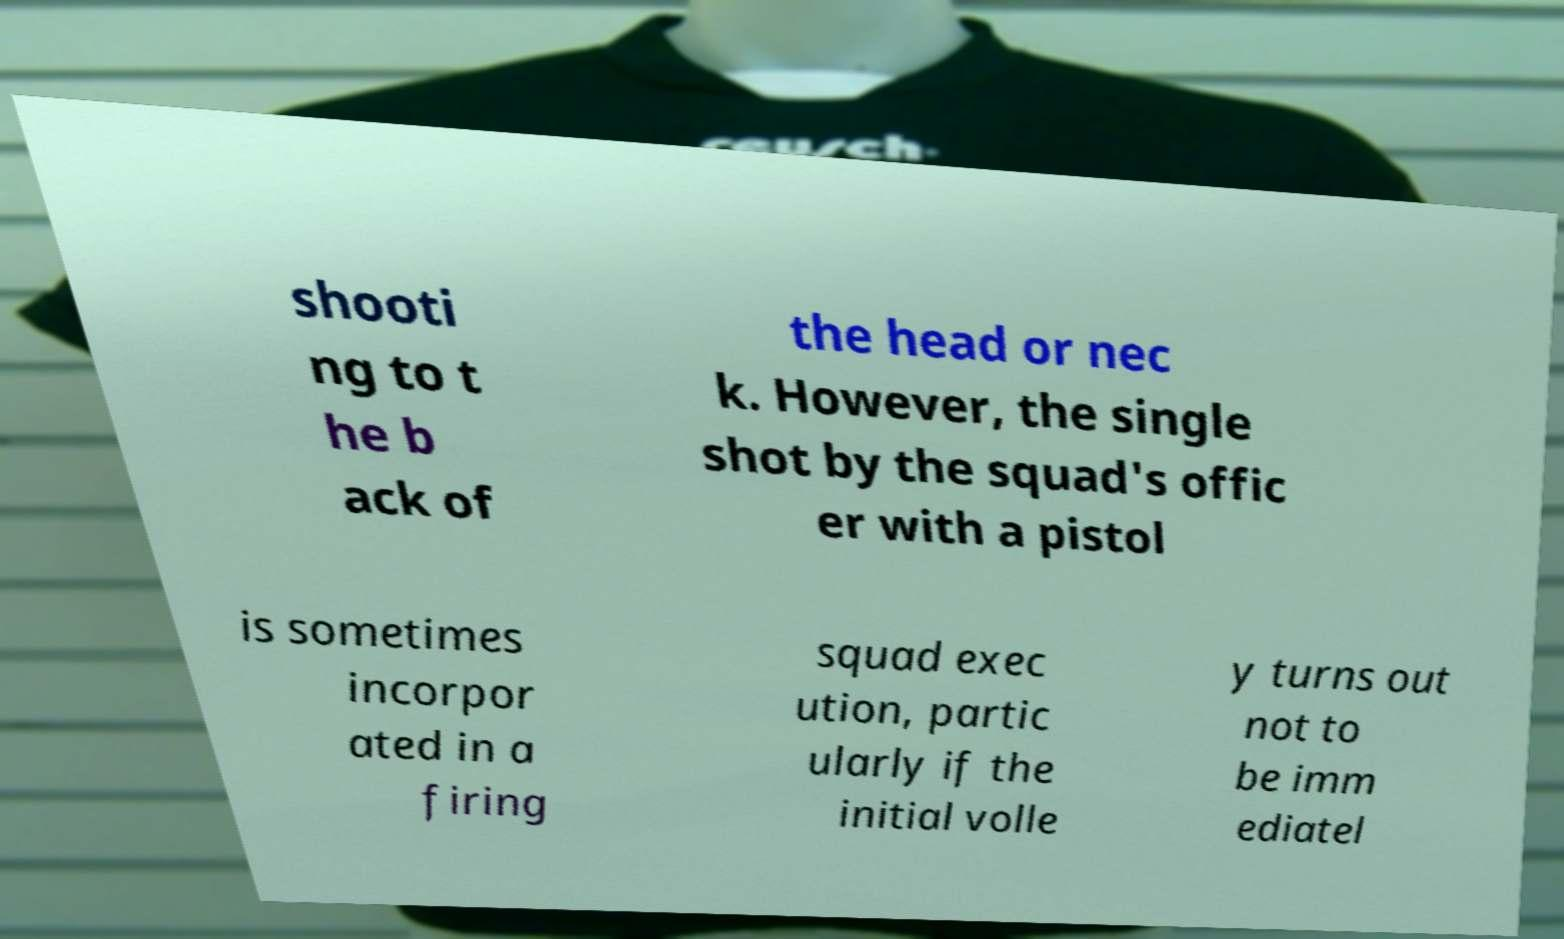Could you assist in decoding the text presented in this image and type it out clearly? shooti ng to t he b ack of the head or nec k. However, the single shot by the squad's offic er with a pistol is sometimes incorpor ated in a firing squad exec ution, partic ularly if the initial volle y turns out not to be imm ediatel 